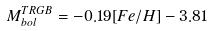Convert formula to latex. <formula><loc_0><loc_0><loc_500><loc_500>M _ { b o l } ^ { T R G B } = - 0 . 1 9 [ F e / H ] - 3 . 8 1</formula> 